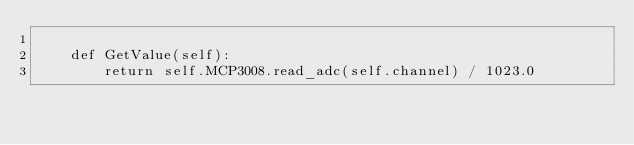Convert code to text. <code><loc_0><loc_0><loc_500><loc_500><_Python_>
    def GetValue(self):
        return self.MCP3008.read_adc(self.channel) / 1023.0

</code> 